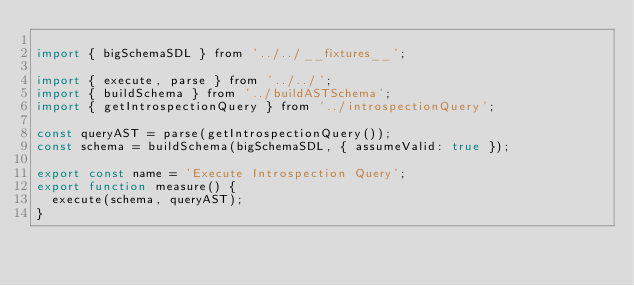<code> <loc_0><loc_0><loc_500><loc_500><_JavaScript_>
import { bigSchemaSDL } from '../../__fixtures__';

import { execute, parse } from '../../';
import { buildSchema } from '../buildASTSchema';
import { getIntrospectionQuery } from '../introspectionQuery';

const queryAST = parse(getIntrospectionQuery());
const schema = buildSchema(bigSchemaSDL, { assumeValid: true });

export const name = 'Execute Introspection Query';
export function measure() {
  execute(schema, queryAST);
}
</code> 